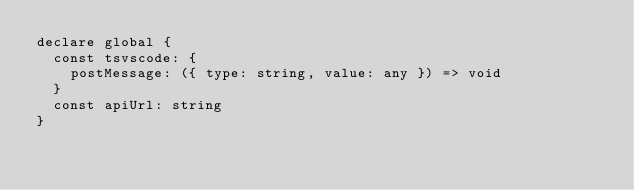<code> <loc_0><loc_0><loc_500><loc_500><_TypeScript_>declare global {
  const tsvscode: {
    postMessage: ({ type: string, value: any }) => void
  }
  const apiUrl: string
}</code> 